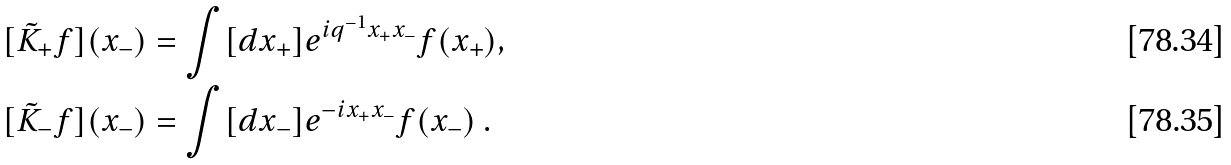Convert formula to latex. <formula><loc_0><loc_0><loc_500><loc_500>[ \tilde { K } _ { + } f ] ( x _ { - } ) & = \int [ d x _ { + } ] e ^ { i q ^ { - 1 } x _ { + } x _ { - } } f ( x _ { + } ) , \\ [ \tilde { K } _ { - } f ] ( x _ { - } ) & = \int [ d x _ { - } ] e ^ { - i x _ { + } x _ { - } } f ( x _ { - } ) \ .</formula> 